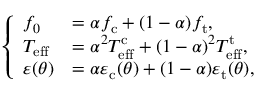Convert formula to latex. <formula><loc_0><loc_0><loc_500><loc_500>\left \{ \begin{array} { l l } { f _ { 0 } } & { = \alpha f _ { c } + ( 1 - \alpha ) f _ { t } , } \\ { T _ { e f f } } & { = \alpha ^ { 2 } T _ { e f f } ^ { c } + ( 1 - \alpha ) ^ { 2 } T _ { e f f } ^ { t } , } \\ { \varepsilon ( \theta ) } & { = \alpha \varepsilon _ { c } ( \theta ) + ( 1 - \alpha ) \varepsilon _ { t } ( \theta ) , } \end{array}</formula> 